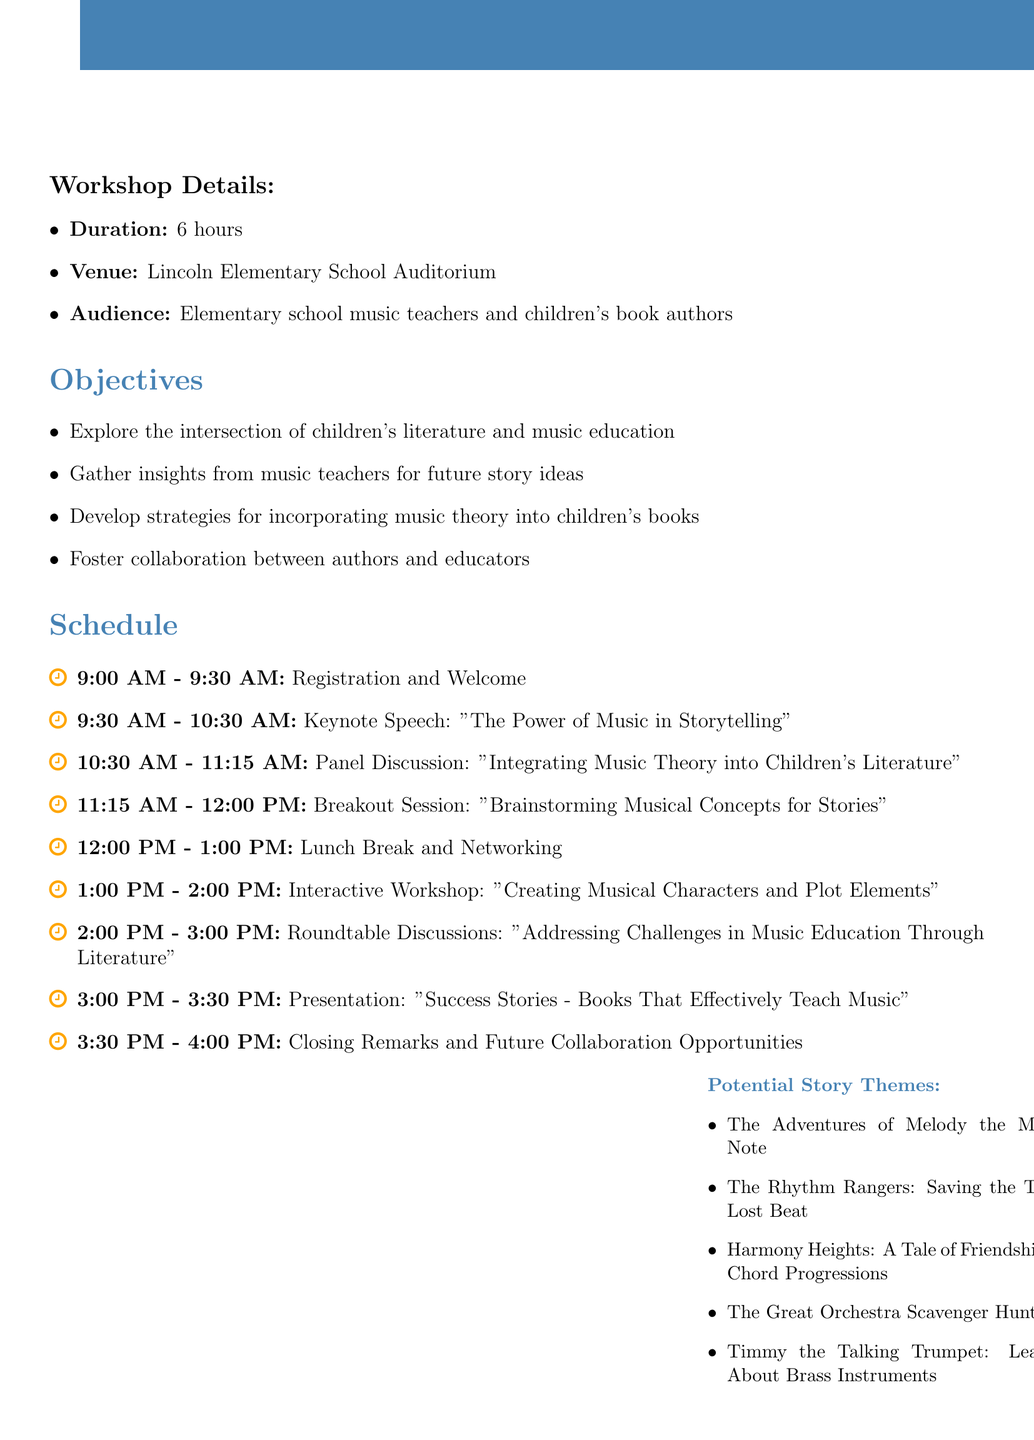What is the title of the workshop? The title of the workshop is explicitly stated at the beginning of the document.
Answer: Harmonizing Stories and Melodies: A Collaborative Workshop for Children's Literature and Music Education Who is the keynote speaker? The document specifies the speaker during the keynote speech section.
Answer: Dr. Emily Thompson What time does the workshop start? The starting time is indicated in the schedule section of the document.
Answer: 9:00 AM How many hours is the workshop planned for? The total duration of the workshop is clearly mentioned in the details section.
Answer: 6 hours What is one of the breakout session topics? The document lists various activities and topics within the schedule, including breakout session topics.
Answer: Brainstorming Musical Concepts for Stories Which venue is hosting the workshop? The specific location for the workshop is given in the workshop details.
Answer: Lincoln Elementary School Auditorium What kind of materials are needed for the workshop? The document outlines essential materials required for the workshop in an organized list.
Answer: Projector and screen What is a potential story theme listed in the document? The document provides examples of potential story themes as part of the agenda.
Answer: The Adventures of Melody the Musical Note What is one objective of the workshop? The objectives of the workshop are summarized in a list format in the document.
Answer: Foster collaboration between authors and educators 